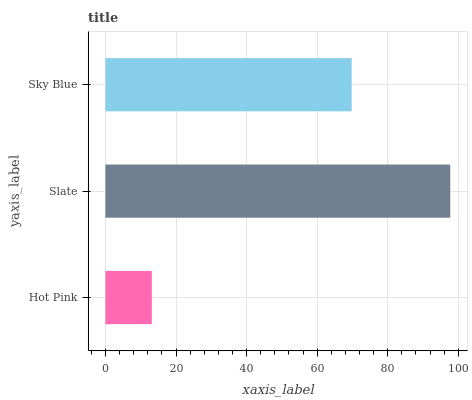Is Hot Pink the minimum?
Answer yes or no. Yes. Is Slate the maximum?
Answer yes or no. Yes. Is Sky Blue the minimum?
Answer yes or no. No. Is Sky Blue the maximum?
Answer yes or no. No. Is Slate greater than Sky Blue?
Answer yes or no. Yes. Is Sky Blue less than Slate?
Answer yes or no. Yes. Is Sky Blue greater than Slate?
Answer yes or no. No. Is Slate less than Sky Blue?
Answer yes or no. No. Is Sky Blue the high median?
Answer yes or no. Yes. Is Sky Blue the low median?
Answer yes or no. Yes. Is Hot Pink the high median?
Answer yes or no. No. Is Slate the low median?
Answer yes or no. No. 